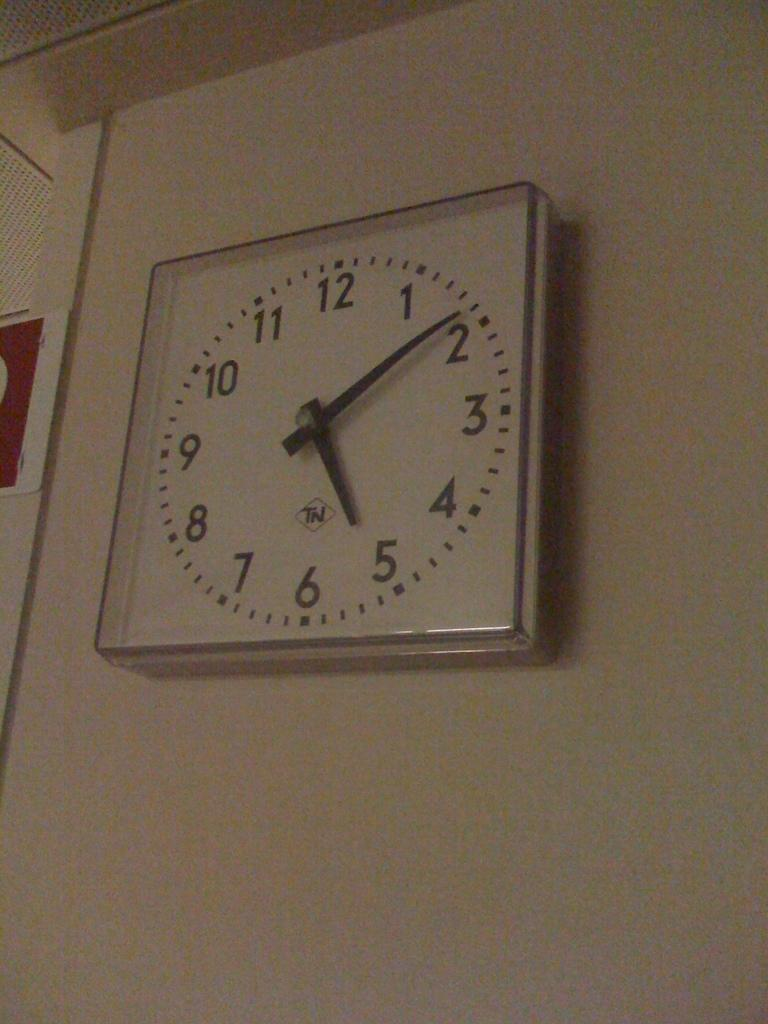Provide a one-sentence caption for the provided image. wall clock displaying the time five o'clock and nine minutes. 